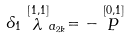Convert formula to latex. <formula><loc_0><loc_0><loc_500><loc_500>\delta _ { 1 } \stackrel { [ 1 , 1 ] } { \lambda } _ { a _ { 2 k } } = - \stackrel { [ 0 , 1 ] } { P }</formula> 